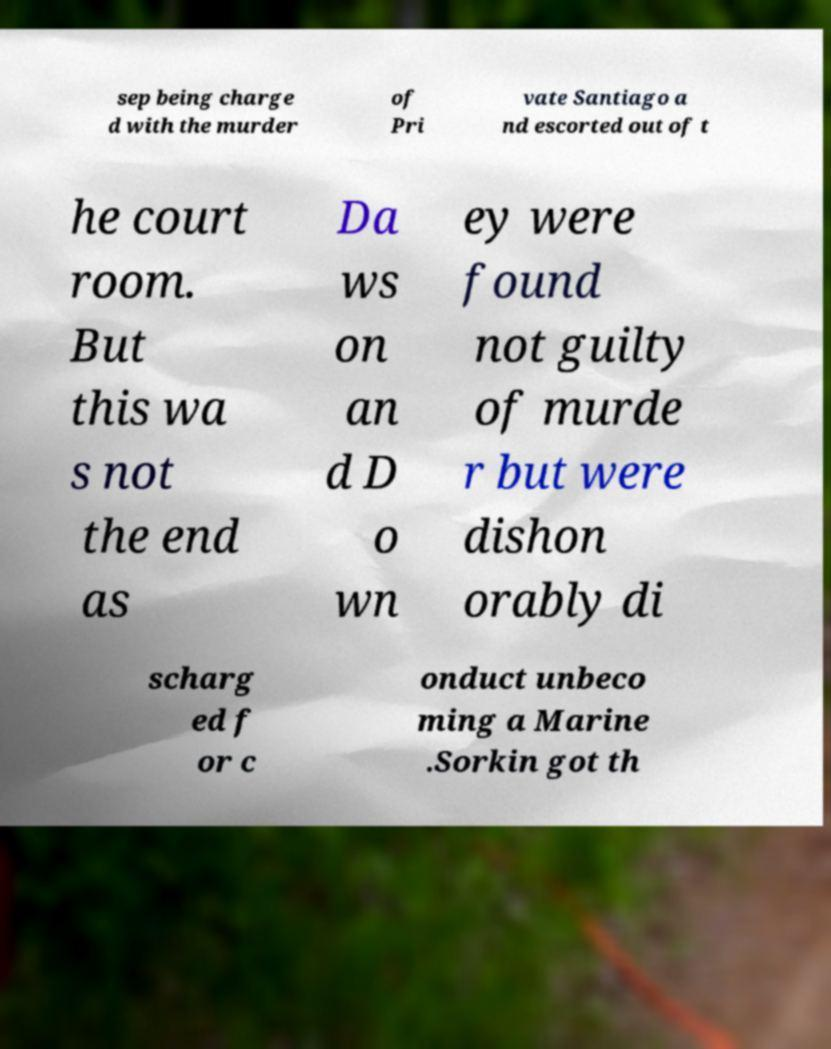For documentation purposes, I need the text within this image transcribed. Could you provide that? sep being charge d with the murder of Pri vate Santiago a nd escorted out of t he court room. But this wa s not the end as Da ws on an d D o wn ey were found not guilty of murde r but were dishon orably di scharg ed f or c onduct unbeco ming a Marine .Sorkin got th 